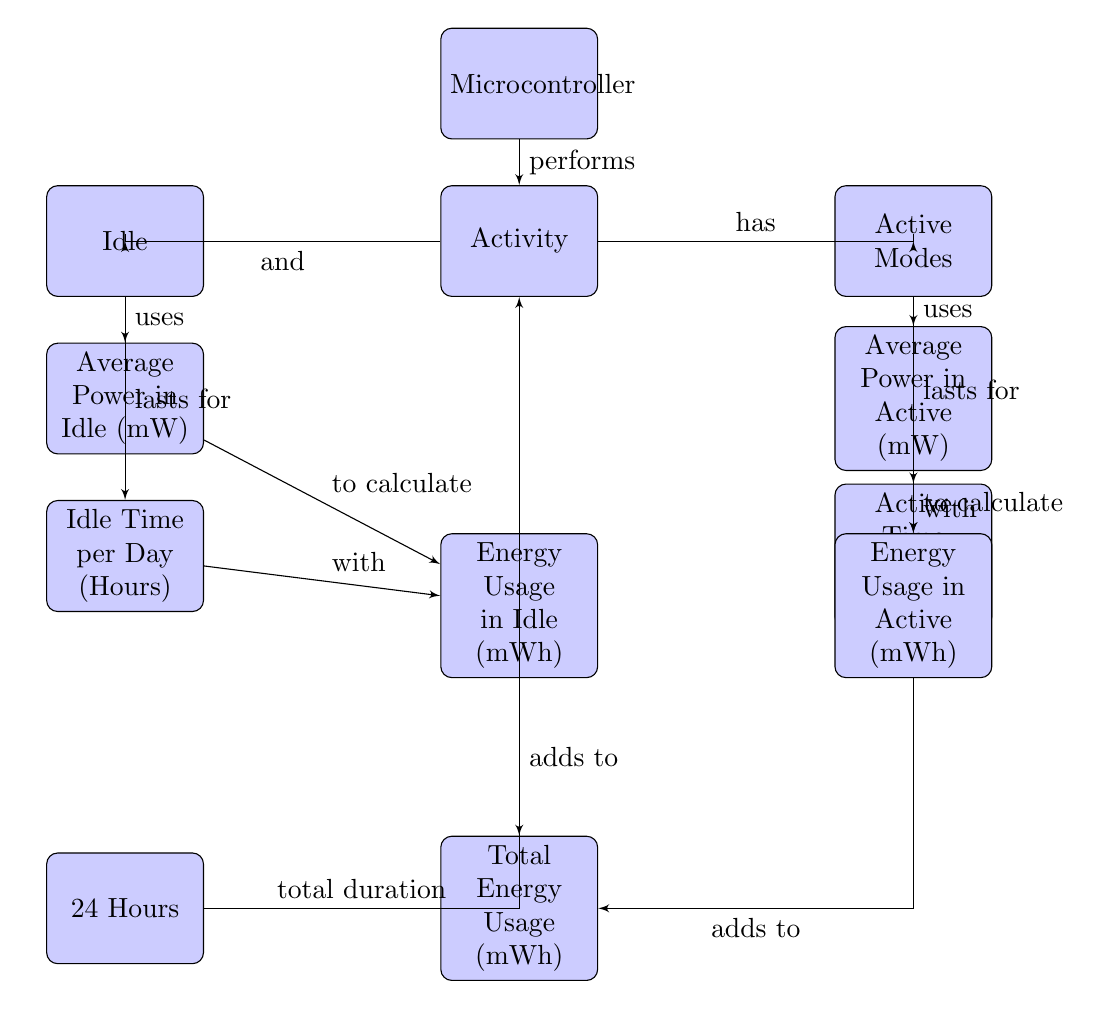What is the average power usage in Idle mode? The diagram shows the block labeled "Average Power in Idle (mW)" directly connected to the "Idle" block. It indicates that this block is responsible for the power used during idle times. The exact value is not explicit in the diagram, but it's presented here to represent the concept.
Answer: Average Power in Idle (mW) What does the "Activity" block have? The "Activity" block has two distinct states, "Idle" and "Active Modes", which it connects with the "has" relationship arrow. This indicates that both modes are part of the activity of the microcontroller.
Answer: Idle and Active Modes How many hours of Idle Time per Day are represented in the diagram? The diagram does not specify an explicit value for "Idle Time per Day (Hours)", but it connects with both "Energy Usage in Idle (mWh)" and "Total Energy Usage (mWh)" indicating its relevance in energy calculations. Therefore, the exact number remains unspecified.
Answer: Not specified What are the total energy and power usages dependent on? The total energy usage is calculated by adding "Energy Usage in Active (mWh)" and "Energy Usage in Idle (mWh)". This means both active and idle modes' energy consumption during their respective times contributes to the total energy used by the microcontroller.
Answer: Energy Usage in Active and Energy Usage in Idle What is the connection between the "Total Time" block and "Activity"? The "Total Time" block is connected to the "Activity" block via a "total duration" relationship, which signifies that the total duration of 24 hours contributes to the total activity monitored by the microcontroller, influencing its power consumption calculations.
Answer: Total duration 